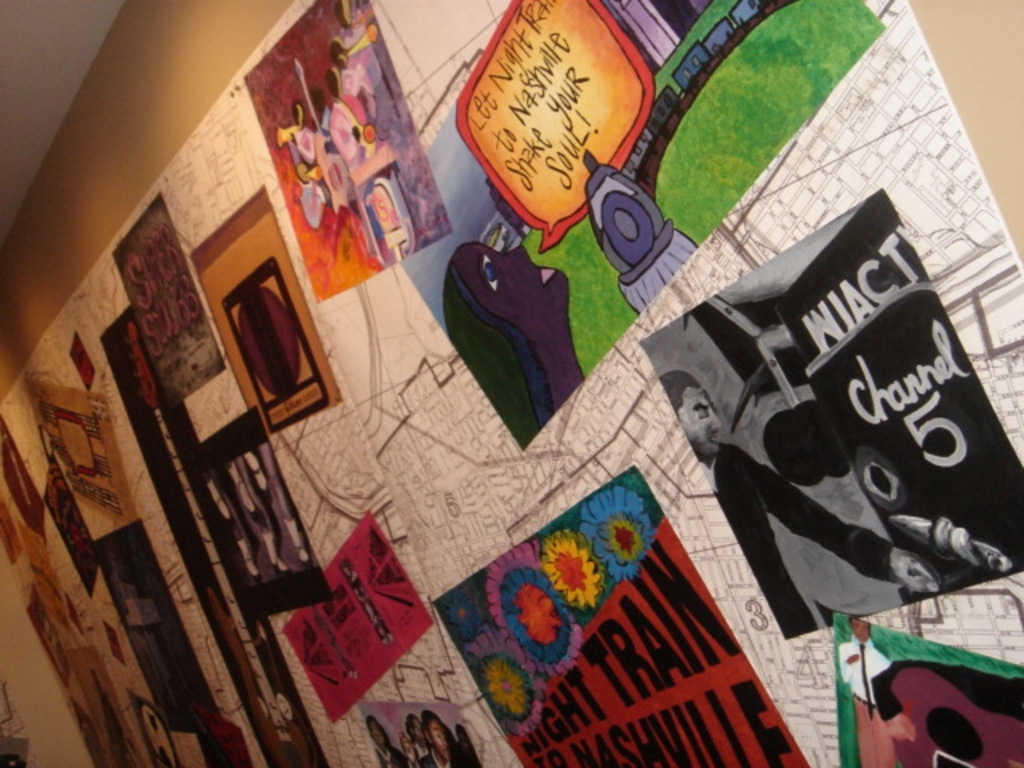Provide a one-sentence caption for the provided image. The image shows a vibrant collage of various posters and artwork on a wall, including a standout piece that invites viewers to 'Let Night Train to Nashville Shake Your Soul,' surrounded by other colorful and eclectic art elements. 